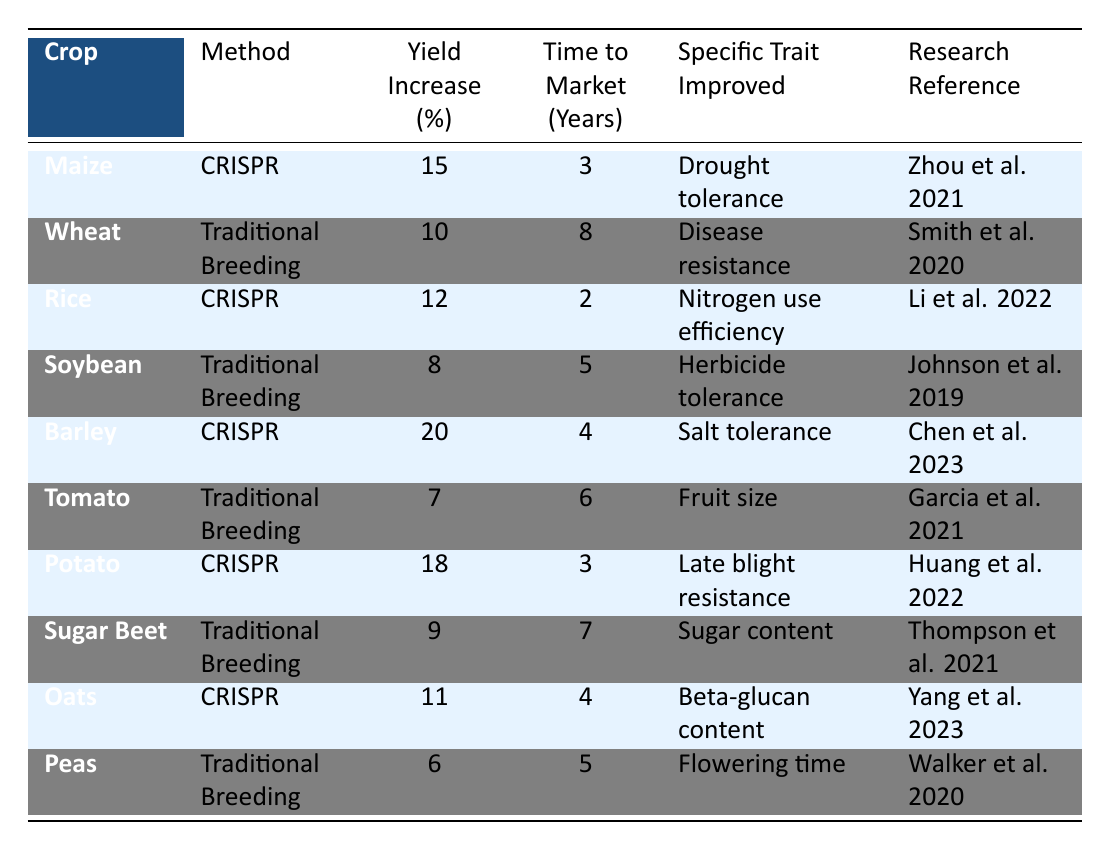What is the Crop with the highest yield increase using CRISPR? By examining the table, the crop with the highest yield increase under the CRISPR method is Barley, showing a 20% increase.
Answer: Barley How long does it take to bring Sugar Beet to market using Traditional Breeding? According to the table, the Time to Market for Sugar Beet using Traditional Breeding is 7 years.
Answer: 7 years Which method resulted in a higher yield increase for Potato? The table indicates that the CRISPR method resulted in an 18% yield increase for Potato, whereas Traditional Breeding is not used for Potato in the data. Therefore, CRISPR is superior for this crop.
Answer: CRISPR What is the average yield increase for crops improved by Traditional Breeding? To find the average, we need the Yield Increases for all crops using Traditional Breeding: 10 (Wheat) + 8 (Soybean) + 7 (Tomato) + 9 (Sugar Beet) + 6 (Peas) = 40. There are 5 data points, so the average is 40/5 = 8.
Answer: 8 Is the Time to Market for CRISPR improved crops generally less than for Traditional Breeding? By comparing the Time to Market values from the table, CRISPR crops average 3.2 years (3+2+4+3+4=16 and 16/5) and Traditional Breeding crops average 6 years (8+5+6+7+5=31 and 31/5). Since 3.2 < 6, the statement is true.
Answer: Yes Which specific trait was improved in the highest yielding crop via CRISPR? From the table, Barley achieved the highest yield increase (20%) via CRISPR, with Salt tolerance being the specific trait improved.
Answer: Salt tolerance What is the yield increase difference between the best-performing CRISPR crop and the worst-performing Traditional Breeding crop? The best-performing CRISPR crop is Barley (20% yield increase), while the worst-performing Traditional Breeding crop is Tomato (7% yield increase). Their difference is 20 - 7 = 13%.
Answer: 13% How many crops in the table had a yield increase below 10%? By checking the table stat, the crops with a yield increase below 10% are Soybean (8%), Tomato (7%), Sugar Beet (9%), and Peas (6%). Thus, there are 4 crops in total.
Answer: 4 Which CRISPR crop improved nitrogen use efficiency, and what was its yield increase? Referring to the table, Rice is the CRISPR crop that improved nitrogen use efficiency, resulting in a yield increase of 12%.
Answer: Rice, 12% What is the longest Time to Market among the crops, and which crop does it correspond to? The longest Time to Market listed is 8 years, corresponding to Wheat, as shown in the table.
Answer: Wheat, 8 years Does Oats have a yield increase higher than the average for Traditional Breeding crops? The yield increase for Oats is 11%. The average for Traditional Breeding crops is 8%. Since 11 > 8, Oats does have a higher yield increase.
Answer: Yes 